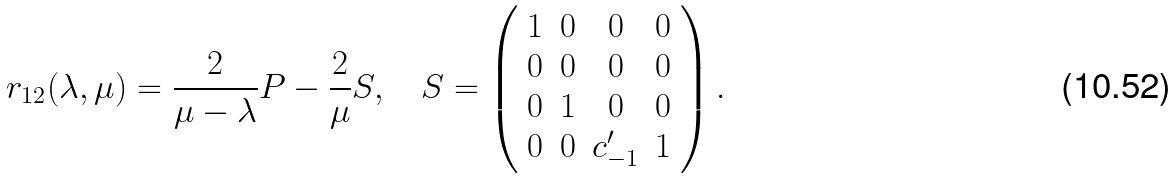<formula> <loc_0><loc_0><loc_500><loc_500>r _ { 1 2 } ( \lambda , \mu ) = \frac { 2 } { \mu - \lambda } P - \frac { 2 } { \mu } S , \quad S = \left ( \begin{array} { c c c c } 1 & 0 & 0 & 0 \\ 0 & 0 & 0 & 0 \\ 0 & 1 & 0 & 0 \\ 0 & 0 & c ^ { \prime } _ { - 1 } & 1 \end{array} \right ) .</formula> 